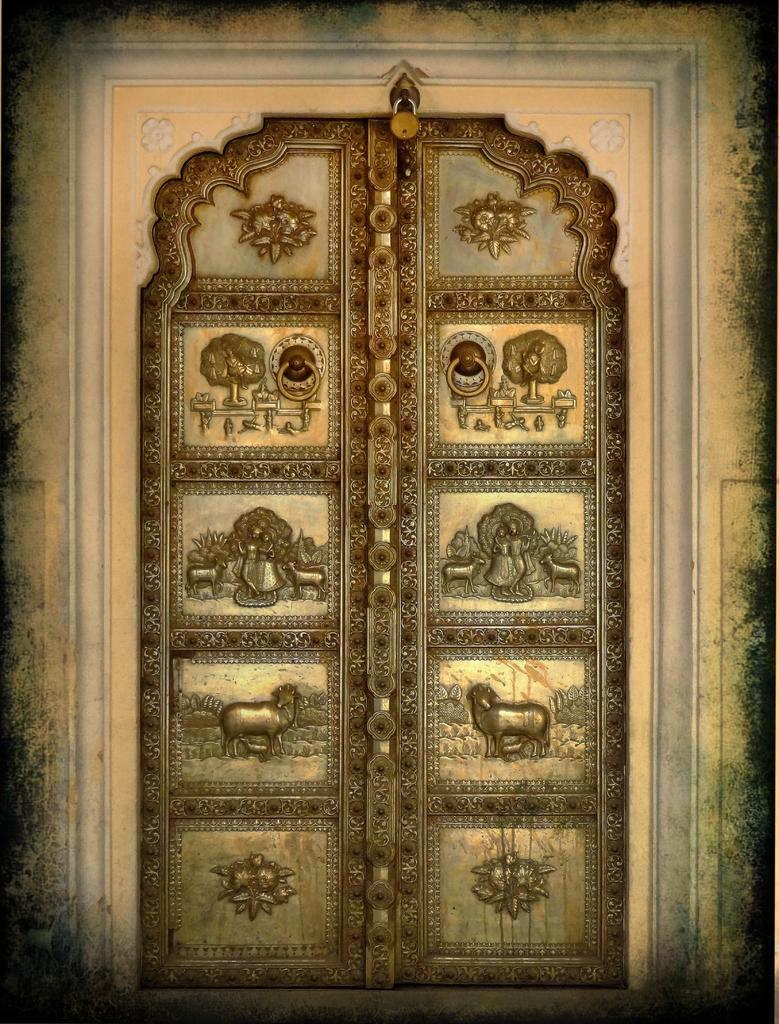What is present in the image that serves as an entrance or exit? There is a door in the image. What can be seen on the door? There are pictures on the door. What type of yoke is used to carry the pictures on the door? There is no yoke present in the image, and the pictures are not being carried by any object. 